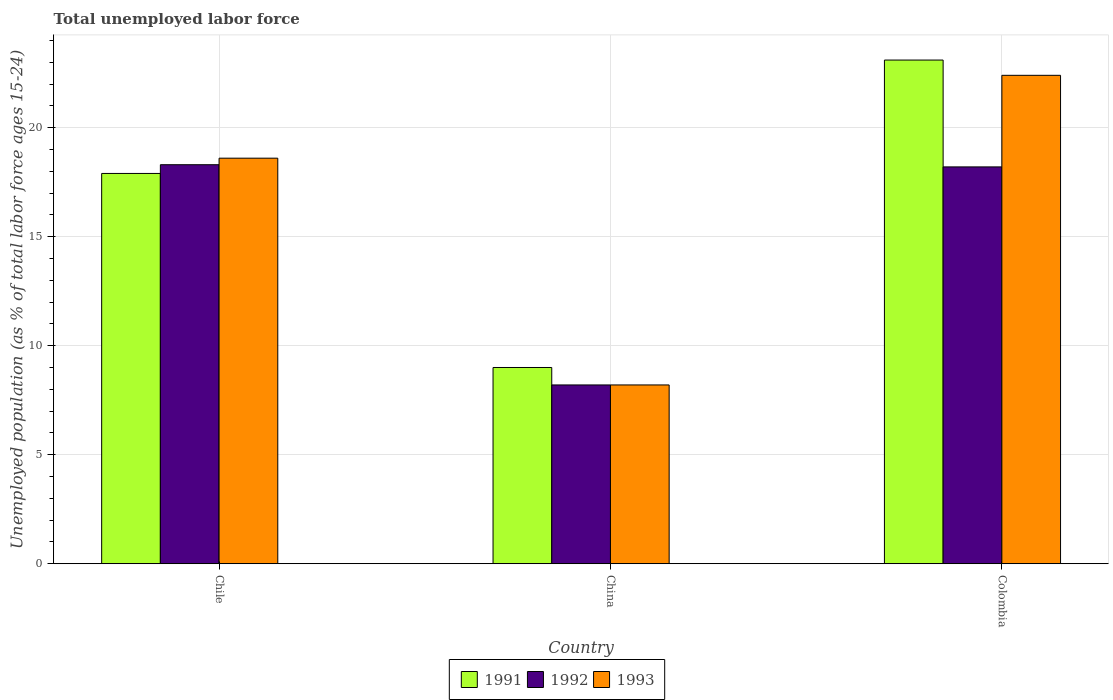How many different coloured bars are there?
Ensure brevity in your answer.  3. Are the number of bars on each tick of the X-axis equal?
Keep it short and to the point. Yes. In how many cases, is the number of bars for a given country not equal to the number of legend labels?
Offer a very short reply. 0. What is the percentage of unemployed population in in 1992 in Colombia?
Your response must be concise. 18.2. Across all countries, what is the maximum percentage of unemployed population in in 1991?
Offer a terse response. 23.1. Across all countries, what is the minimum percentage of unemployed population in in 1992?
Make the answer very short. 8.2. In which country was the percentage of unemployed population in in 1991 maximum?
Offer a very short reply. Colombia. What is the total percentage of unemployed population in in 1991 in the graph?
Offer a very short reply. 50. What is the difference between the percentage of unemployed population in in 1992 in Chile and that in Colombia?
Ensure brevity in your answer.  0.1. What is the difference between the percentage of unemployed population in in 1992 in Chile and the percentage of unemployed population in in 1993 in China?
Keep it short and to the point. 10.1. What is the average percentage of unemployed population in in 1991 per country?
Your answer should be compact. 16.67. What is the difference between the percentage of unemployed population in of/in 1992 and percentage of unemployed population in of/in 1991 in China?
Keep it short and to the point. -0.8. In how many countries, is the percentage of unemployed population in in 1991 greater than 3 %?
Your response must be concise. 3. What is the ratio of the percentage of unemployed population in in 1991 in Chile to that in China?
Provide a succinct answer. 1.99. Is the percentage of unemployed population in in 1992 in China less than that in Colombia?
Offer a terse response. Yes. What is the difference between the highest and the second highest percentage of unemployed population in in 1991?
Your response must be concise. 8.9. What is the difference between the highest and the lowest percentage of unemployed population in in 1992?
Make the answer very short. 10.1. Is the sum of the percentage of unemployed population in in 1992 in China and Colombia greater than the maximum percentage of unemployed population in in 1991 across all countries?
Ensure brevity in your answer.  Yes. What does the 2nd bar from the left in Colombia represents?
Offer a terse response. 1992. Is it the case that in every country, the sum of the percentage of unemployed population in in 1991 and percentage of unemployed population in in 1992 is greater than the percentage of unemployed population in in 1993?
Make the answer very short. Yes. How many bars are there?
Ensure brevity in your answer.  9. Are all the bars in the graph horizontal?
Offer a very short reply. No. How many countries are there in the graph?
Provide a succinct answer. 3. What is the difference between two consecutive major ticks on the Y-axis?
Offer a terse response. 5. Does the graph contain grids?
Your answer should be compact. Yes. How are the legend labels stacked?
Keep it short and to the point. Horizontal. What is the title of the graph?
Keep it short and to the point. Total unemployed labor force. Does "2005" appear as one of the legend labels in the graph?
Make the answer very short. No. What is the label or title of the Y-axis?
Offer a terse response. Unemployed population (as % of total labor force ages 15-24). What is the Unemployed population (as % of total labor force ages 15-24) of 1991 in Chile?
Keep it short and to the point. 17.9. What is the Unemployed population (as % of total labor force ages 15-24) of 1992 in Chile?
Provide a succinct answer. 18.3. What is the Unemployed population (as % of total labor force ages 15-24) in 1993 in Chile?
Offer a terse response. 18.6. What is the Unemployed population (as % of total labor force ages 15-24) in 1991 in China?
Ensure brevity in your answer.  9. What is the Unemployed population (as % of total labor force ages 15-24) of 1992 in China?
Your answer should be very brief. 8.2. What is the Unemployed population (as % of total labor force ages 15-24) in 1993 in China?
Your answer should be very brief. 8.2. What is the Unemployed population (as % of total labor force ages 15-24) of 1991 in Colombia?
Your answer should be very brief. 23.1. What is the Unemployed population (as % of total labor force ages 15-24) in 1992 in Colombia?
Offer a very short reply. 18.2. What is the Unemployed population (as % of total labor force ages 15-24) of 1993 in Colombia?
Ensure brevity in your answer.  22.4. Across all countries, what is the maximum Unemployed population (as % of total labor force ages 15-24) in 1991?
Provide a short and direct response. 23.1. Across all countries, what is the maximum Unemployed population (as % of total labor force ages 15-24) in 1992?
Offer a terse response. 18.3. Across all countries, what is the maximum Unemployed population (as % of total labor force ages 15-24) in 1993?
Offer a very short reply. 22.4. Across all countries, what is the minimum Unemployed population (as % of total labor force ages 15-24) of 1991?
Keep it short and to the point. 9. Across all countries, what is the minimum Unemployed population (as % of total labor force ages 15-24) of 1992?
Your response must be concise. 8.2. Across all countries, what is the minimum Unemployed population (as % of total labor force ages 15-24) of 1993?
Provide a succinct answer. 8.2. What is the total Unemployed population (as % of total labor force ages 15-24) in 1991 in the graph?
Offer a terse response. 50. What is the total Unemployed population (as % of total labor force ages 15-24) in 1992 in the graph?
Provide a succinct answer. 44.7. What is the total Unemployed population (as % of total labor force ages 15-24) of 1993 in the graph?
Your answer should be very brief. 49.2. What is the difference between the Unemployed population (as % of total labor force ages 15-24) in 1991 in Chile and that in China?
Give a very brief answer. 8.9. What is the difference between the Unemployed population (as % of total labor force ages 15-24) in 1992 in Chile and that in Colombia?
Ensure brevity in your answer.  0.1. What is the difference between the Unemployed population (as % of total labor force ages 15-24) of 1993 in Chile and that in Colombia?
Provide a succinct answer. -3.8. What is the difference between the Unemployed population (as % of total labor force ages 15-24) of 1991 in China and that in Colombia?
Offer a very short reply. -14.1. What is the difference between the Unemployed population (as % of total labor force ages 15-24) of 1992 in China and that in Colombia?
Your answer should be very brief. -10. What is the difference between the Unemployed population (as % of total labor force ages 15-24) in 1993 in China and that in Colombia?
Keep it short and to the point. -14.2. What is the difference between the Unemployed population (as % of total labor force ages 15-24) in 1991 in Chile and the Unemployed population (as % of total labor force ages 15-24) in 1993 in China?
Your answer should be compact. 9.7. What is the difference between the Unemployed population (as % of total labor force ages 15-24) in 1991 in Chile and the Unemployed population (as % of total labor force ages 15-24) in 1993 in Colombia?
Your answer should be compact. -4.5. What is the difference between the Unemployed population (as % of total labor force ages 15-24) of 1991 in China and the Unemployed population (as % of total labor force ages 15-24) of 1993 in Colombia?
Keep it short and to the point. -13.4. What is the difference between the Unemployed population (as % of total labor force ages 15-24) in 1992 in China and the Unemployed population (as % of total labor force ages 15-24) in 1993 in Colombia?
Offer a very short reply. -14.2. What is the average Unemployed population (as % of total labor force ages 15-24) of 1991 per country?
Your answer should be very brief. 16.67. What is the average Unemployed population (as % of total labor force ages 15-24) of 1992 per country?
Your answer should be compact. 14.9. What is the average Unemployed population (as % of total labor force ages 15-24) in 1993 per country?
Offer a very short reply. 16.4. What is the difference between the Unemployed population (as % of total labor force ages 15-24) of 1991 and Unemployed population (as % of total labor force ages 15-24) of 1993 in Chile?
Your answer should be very brief. -0.7. What is the difference between the Unemployed population (as % of total labor force ages 15-24) in 1992 and Unemployed population (as % of total labor force ages 15-24) in 1993 in Chile?
Give a very brief answer. -0.3. What is the difference between the Unemployed population (as % of total labor force ages 15-24) in 1991 and Unemployed population (as % of total labor force ages 15-24) in 1993 in China?
Your response must be concise. 0.8. What is the ratio of the Unemployed population (as % of total labor force ages 15-24) of 1991 in Chile to that in China?
Provide a succinct answer. 1.99. What is the ratio of the Unemployed population (as % of total labor force ages 15-24) of 1992 in Chile to that in China?
Give a very brief answer. 2.23. What is the ratio of the Unemployed population (as % of total labor force ages 15-24) of 1993 in Chile to that in China?
Give a very brief answer. 2.27. What is the ratio of the Unemployed population (as % of total labor force ages 15-24) in 1991 in Chile to that in Colombia?
Your answer should be very brief. 0.77. What is the ratio of the Unemployed population (as % of total labor force ages 15-24) in 1993 in Chile to that in Colombia?
Provide a succinct answer. 0.83. What is the ratio of the Unemployed population (as % of total labor force ages 15-24) of 1991 in China to that in Colombia?
Your answer should be compact. 0.39. What is the ratio of the Unemployed population (as % of total labor force ages 15-24) in 1992 in China to that in Colombia?
Offer a terse response. 0.45. What is the ratio of the Unemployed population (as % of total labor force ages 15-24) of 1993 in China to that in Colombia?
Ensure brevity in your answer.  0.37. What is the difference between the highest and the second highest Unemployed population (as % of total labor force ages 15-24) in 1991?
Give a very brief answer. 5.2. What is the difference between the highest and the second highest Unemployed population (as % of total labor force ages 15-24) of 1993?
Your answer should be very brief. 3.8. What is the difference between the highest and the lowest Unemployed population (as % of total labor force ages 15-24) of 1991?
Your answer should be compact. 14.1. What is the difference between the highest and the lowest Unemployed population (as % of total labor force ages 15-24) in 1992?
Make the answer very short. 10.1. 